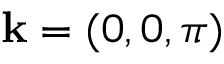<formula> <loc_0><loc_0><loc_500><loc_500>k = ( 0 , 0 , \pi )</formula> 